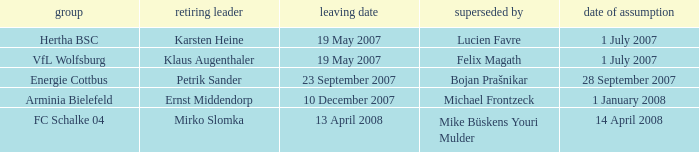When was the appointment date for the manager replaced by Lucien Favre? 1 July 2007. 